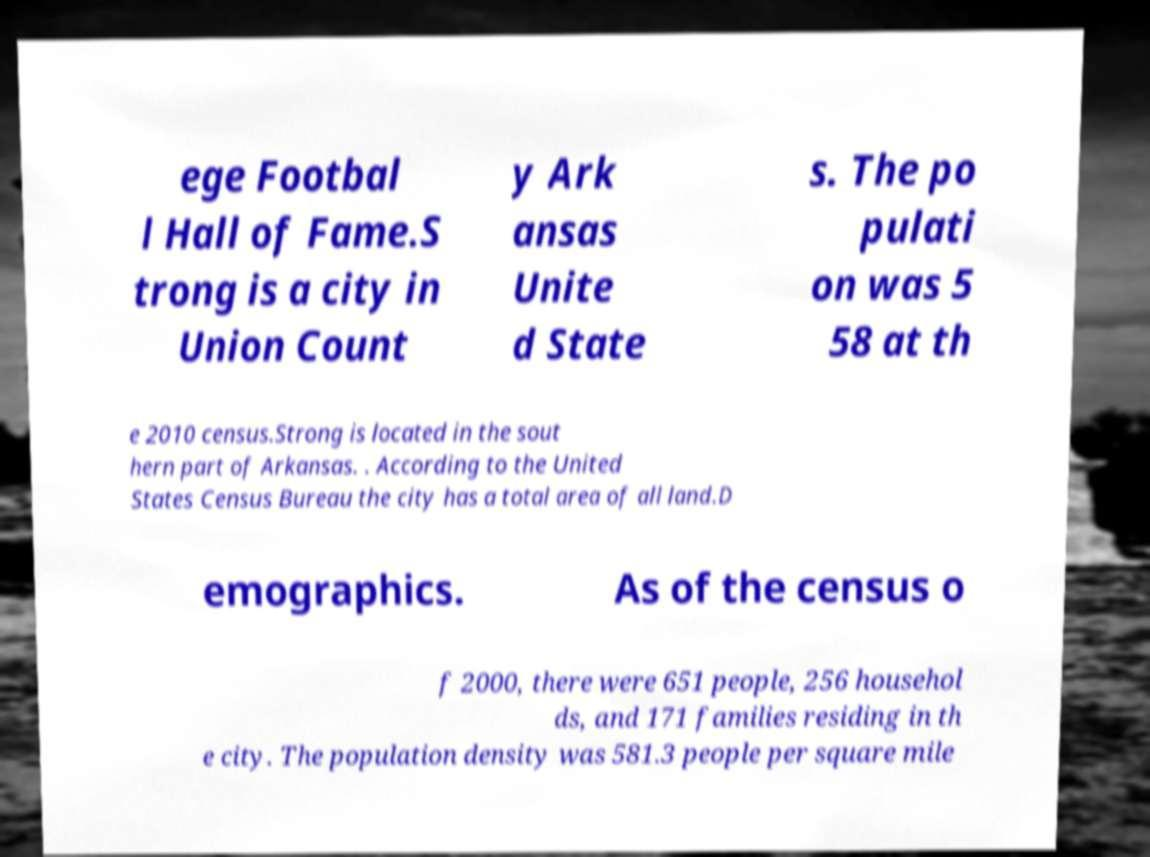Could you assist in decoding the text presented in this image and type it out clearly? ege Footbal l Hall of Fame.S trong is a city in Union Count y Ark ansas Unite d State s. The po pulati on was 5 58 at th e 2010 census.Strong is located in the sout hern part of Arkansas. . According to the United States Census Bureau the city has a total area of all land.D emographics. As of the census o f 2000, there were 651 people, 256 househol ds, and 171 families residing in th e city. The population density was 581.3 people per square mile 